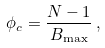Convert formula to latex. <formula><loc_0><loc_0><loc_500><loc_500>\phi _ { c } = \frac { N - 1 } { B _ { \max } } \, ,</formula> 